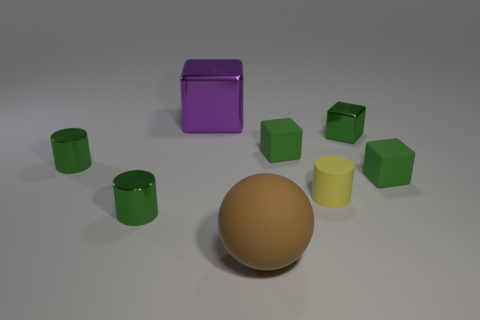Subtract all red balls. How many green blocks are left? 3 Add 1 small brown metal spheres. How many objects exist? 9 Subtract all cylinders. How many objects are left? 5 Add 5 large balls. How many large balls are left? 6 Add 3 metal cubes. How many metal cubes exist? 5 Subtract 0 brown blocks. How many objects are left? 8 Subtract all big yellow matte cylinders. Subtract all yellow cylinders. How many objects are left? 7 